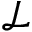Convert formula to latex. <formula><loc_0><loc_0><loc_500><loc_500>\mathcal { L }</formula> 